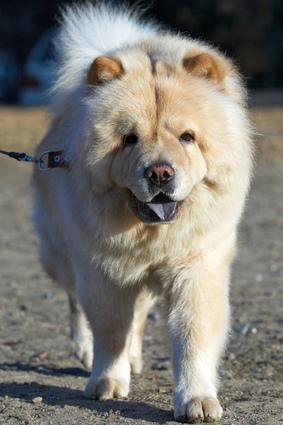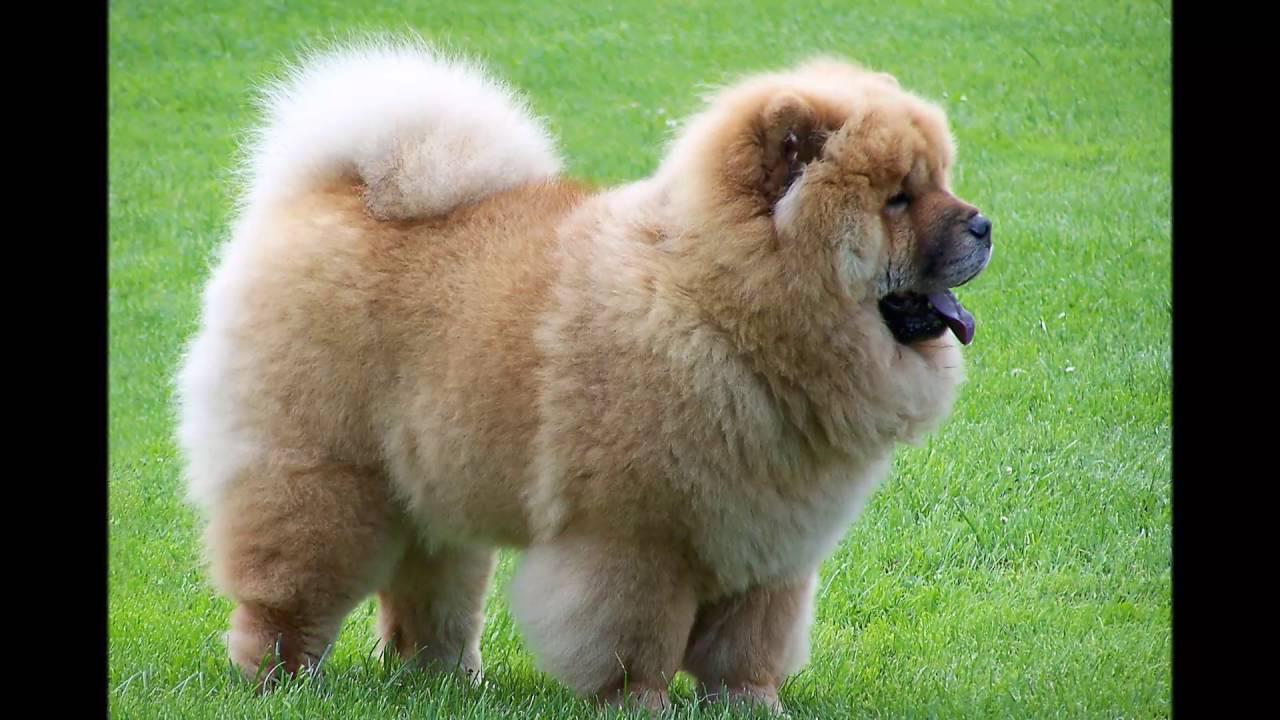The first image is the image on the left, the second image is the image on the right. Given the left and right images, does the statement "One of the images only shows the head of a dog." hold true? Answer yes or no. No. 